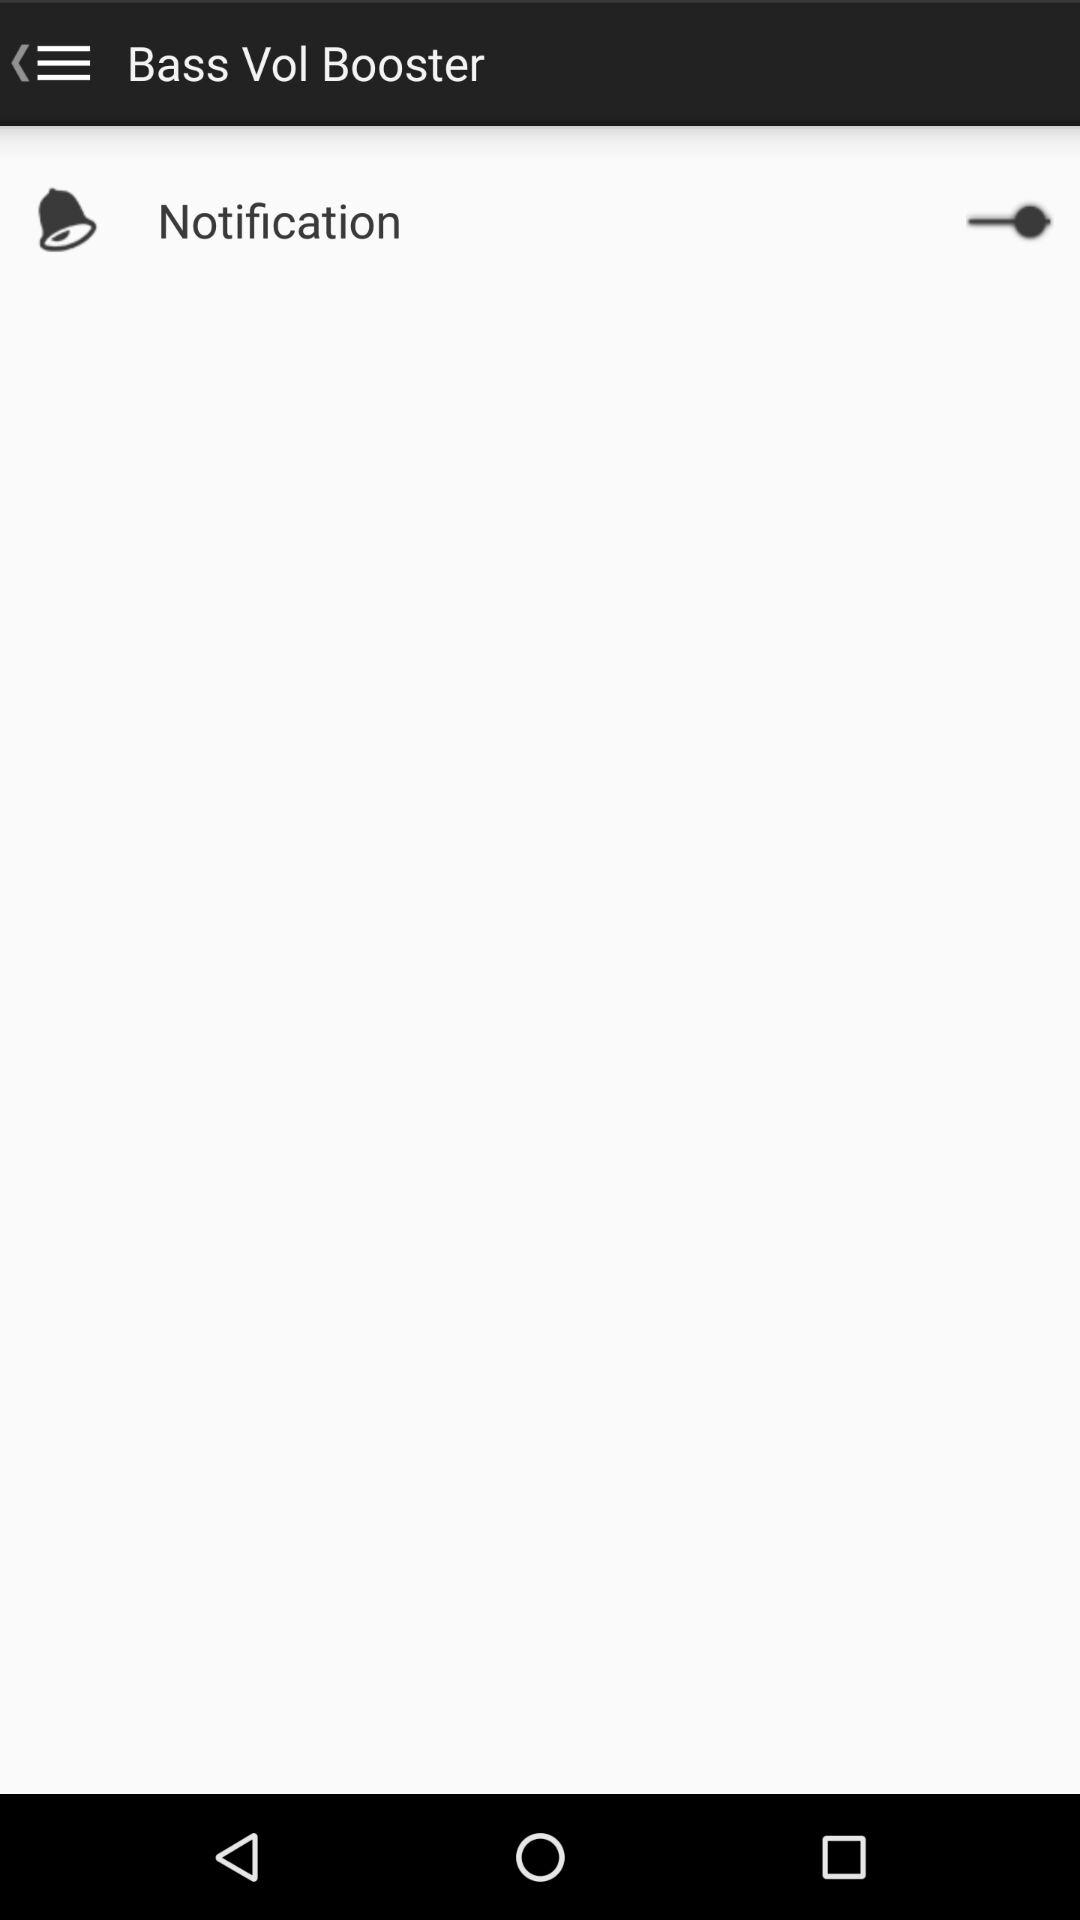What is the name of the application? The name of the application is "Bass Vol Booster". 